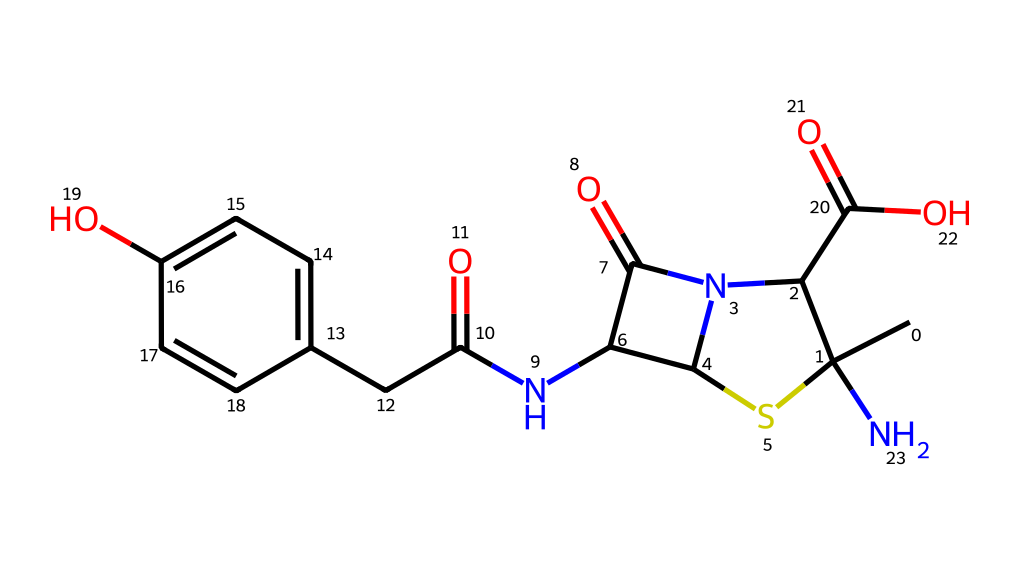What is the molecular formula of amoxicillin? By analyzing the SMILES representation, we can count the number of each atom. The structure consists of carbon (C), hydrogen (H), nitrogen (N), oxygen (O), and sulfur (S) atoms, leading to the molecular formula C16H19N3O5S.
Answer: C16H19N3O5S How many rings are present in the structure of amoxicillin? Upon visual inspection of the chemical structure as understood from its SMILES, there are two rings: a five-membered thiazolidine ring and a six-membered carbon ring.
Answer: 2 What functional groups are present in amoxicillin? The SMILES indicates several functional groups, including an amine (NH) from the amino group, a carboxylic acid (COOH), and a hydroxyl group (OH) attached to the aromatic ring.
Answer: amine, carboxylic acid, hydroxyl What is the significance of the beta-lactam ring in amoxicillin? The beta-lactam is crucial for the antibiotic activity of amoxicillin, as it interferes with bacterial cell wall synthesis. Its presence is indicated by the four-membered cyclic amide structure.
Answer: antibiotic activity How many carbon atoms are in the aromatic ring of amoxicillin? By examining the SMILES, we can determine that the aromatic ring has four carbon atoms, specifically in the structure indicated in the phenolic part.
Answer: 4 Which atom in amoxicillin is responsible for its acidity? The carboxylic acid group (COOH) contains the hydrogen atom that is donated as a proton, which is responsible for the acidic behavior of the molecule.
Answer: hydrogen in carboxylic acid What is the stereochemistry of the amoxicillin molecule? The SMILES notation indicates stereocenters, notably in the five-membered ring and the presence of chiral centers, confirming that amoxicillin has a specific stereochemistry critical for its activity.
Answer: specific stereochemistry 